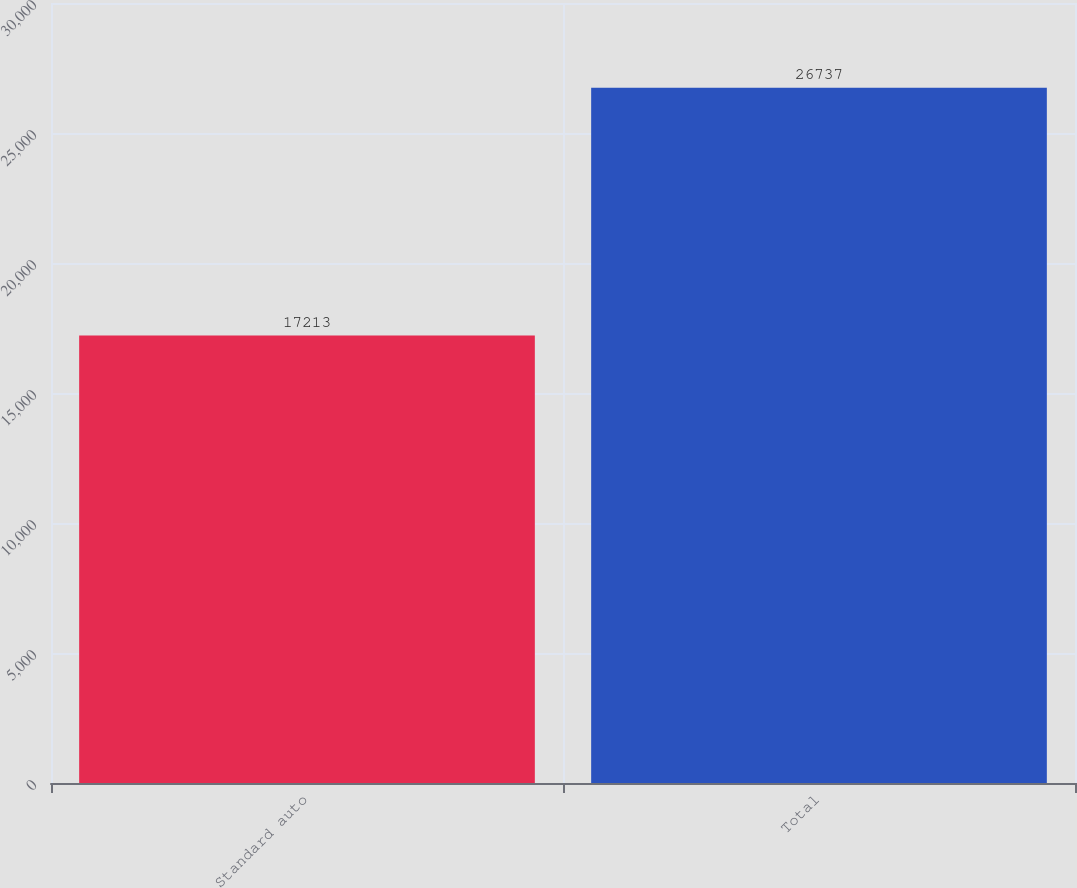Convert chart. <chart><loc_0><loc_0><loc_500><loc_500><bar_chart><fcel>Standard auto<fcel>Total<nl><fcel>17213<fcel>26737<nl></chart> 